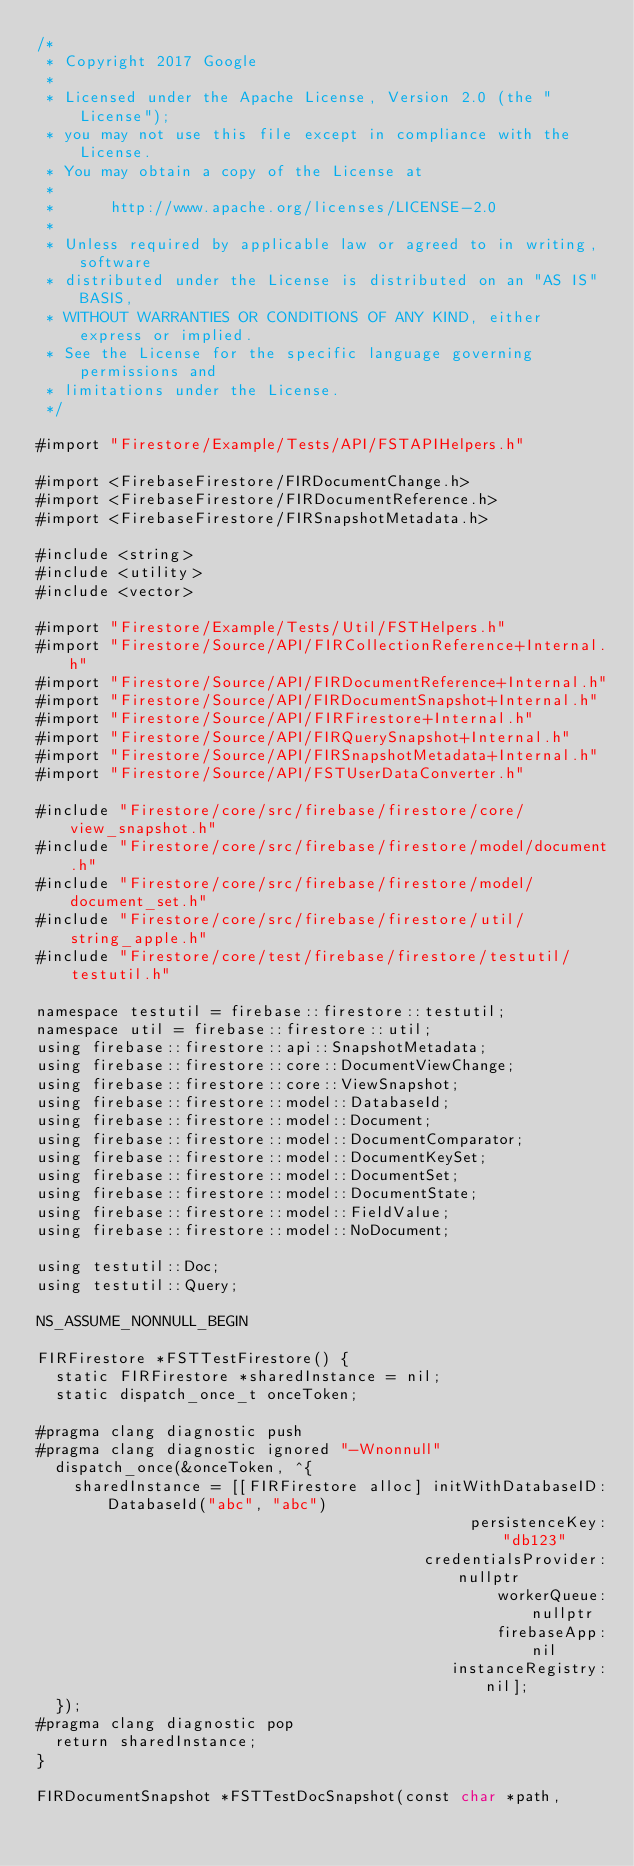Convert code to text. <code><loc_0><loc_0><loc_500><loc_500><_ObjectiveC_>/*
 * Copyright 2017 Google
 *
 * Licensed under the Apache License, Version 2.0 (the "License");
 * you may not use this file except in compliance with the License.
 * You may obtain a copy of the License at
 *
 *      http://www.apache.org/licenses/LICENSE-2.0
 *
 * Unless required by applicable law or agreed to in writing, software
 * distributed under the License is distributed on an "AS IS" BASIS,
 * WITHOUT WARRANTIES OR CONDITIONS OF ANY KIND, either express or implied.
 * See the License for the specific language governing permissions and
 * limitations under the License.
 */

#import "Firestore/Example/Tests/API/FSTAPIHelpers.h"

#import <FirebaseFirestore/FIRDocumentChange.h>
#import <FirebaseFirestore/FIRDocumentReference.h>
#import <FirebaseFirestore/FIRSnapshotMetadata.h>

#include <string>
#include <utility>
#include <vector>

#import "Firestore/Example/Tests/Util/FSTHelpers.h"
#import "Firestore/Source/API/FIRCollectionReference+Internal.h"
#import "Firestore/Source/API/FIRDocumentReference+Internal.h"
#import "Firestore/Source/API/FIRDocumentSnapshot+Internal.h"
#import "Firestore/Source/API/FIRFirestore+Internal.h"
#import "Firestore/Source/API/FIRQuerySnapshot+Internal.h"
#import "Firestore/Source/API/FIRSnapshotMetadata+Internal.h"
#import "Firestore/Source/API/FSTUserDataConverter.h"

#include "Firestore/core/src/firebase/firestore/core/view_snapshot.h"
#include "Firestore/core/src/firebase/firestore/model/document.h"
#include "Firestore/core/src/firebase/firestore/model/document_set.h"
#include "Firestore/core/src/firebase/firestore/util/string_apple.h"
#include "Firestore/core/test/firebase/firestore/testutil/testutil.h"

namespace testutil = firebase::firestore::testutil;
namespace util = firebase::firestore::util;
using firebase::firestore::api::SnapshotMetadata;
using firebase::firestore::core::DocumentViewChange;
using firebase::firestore::core::ViewSnapshot;
using firebase::firestore::model::DatabaseId;
using firebase::firestore::model::Document;
using firebase::firestore::model::DocumentComparator;
using firebase::firestore::model::DocumentKeySet;
using firebase::firestore::model::DocumentSet;
using firebase::firestore::model::DocumentState;
using firebase::firestore::model::FieldValue;
using firebase::firestore::model::NoDocument;

using testutil::Doc;
using testutil::Query;

NS_ASSUME_NONNULL_BEGIN

FIRFirestore *FSTTestFirestore() {
  static FIRFirestore *sharedInstance = nil;
  static dispatch_once_t onceToken;

#pragma clang diagnostic push
#pragma clang diagnostic ignored "-Wnonnull"
  dispatch_once(&onceToken, ^{
    sharedInstance = [[FIRFirestore alloc] initWithDatabaseID:DatabaseId("abc", "abc")
                                               persistenceKey:"db123"
                                          credentialsProvider:nullptr
                                                  workerQueue:nullptr
                                                  firebaseApp:nil
                                             instanceRegistry:nil];
  });
#pragma clang diagnostic pop
  return sharedInstance;
}

FIRDocumentSnapshot *FSTTestDocSnapshot(const char *path,</code> 